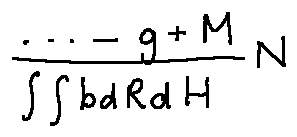<formula> <loc_0><loc_0><loc_500><loc_500>\frac { \cdots - g + M } { \int \int b d R d H } N</formula> 